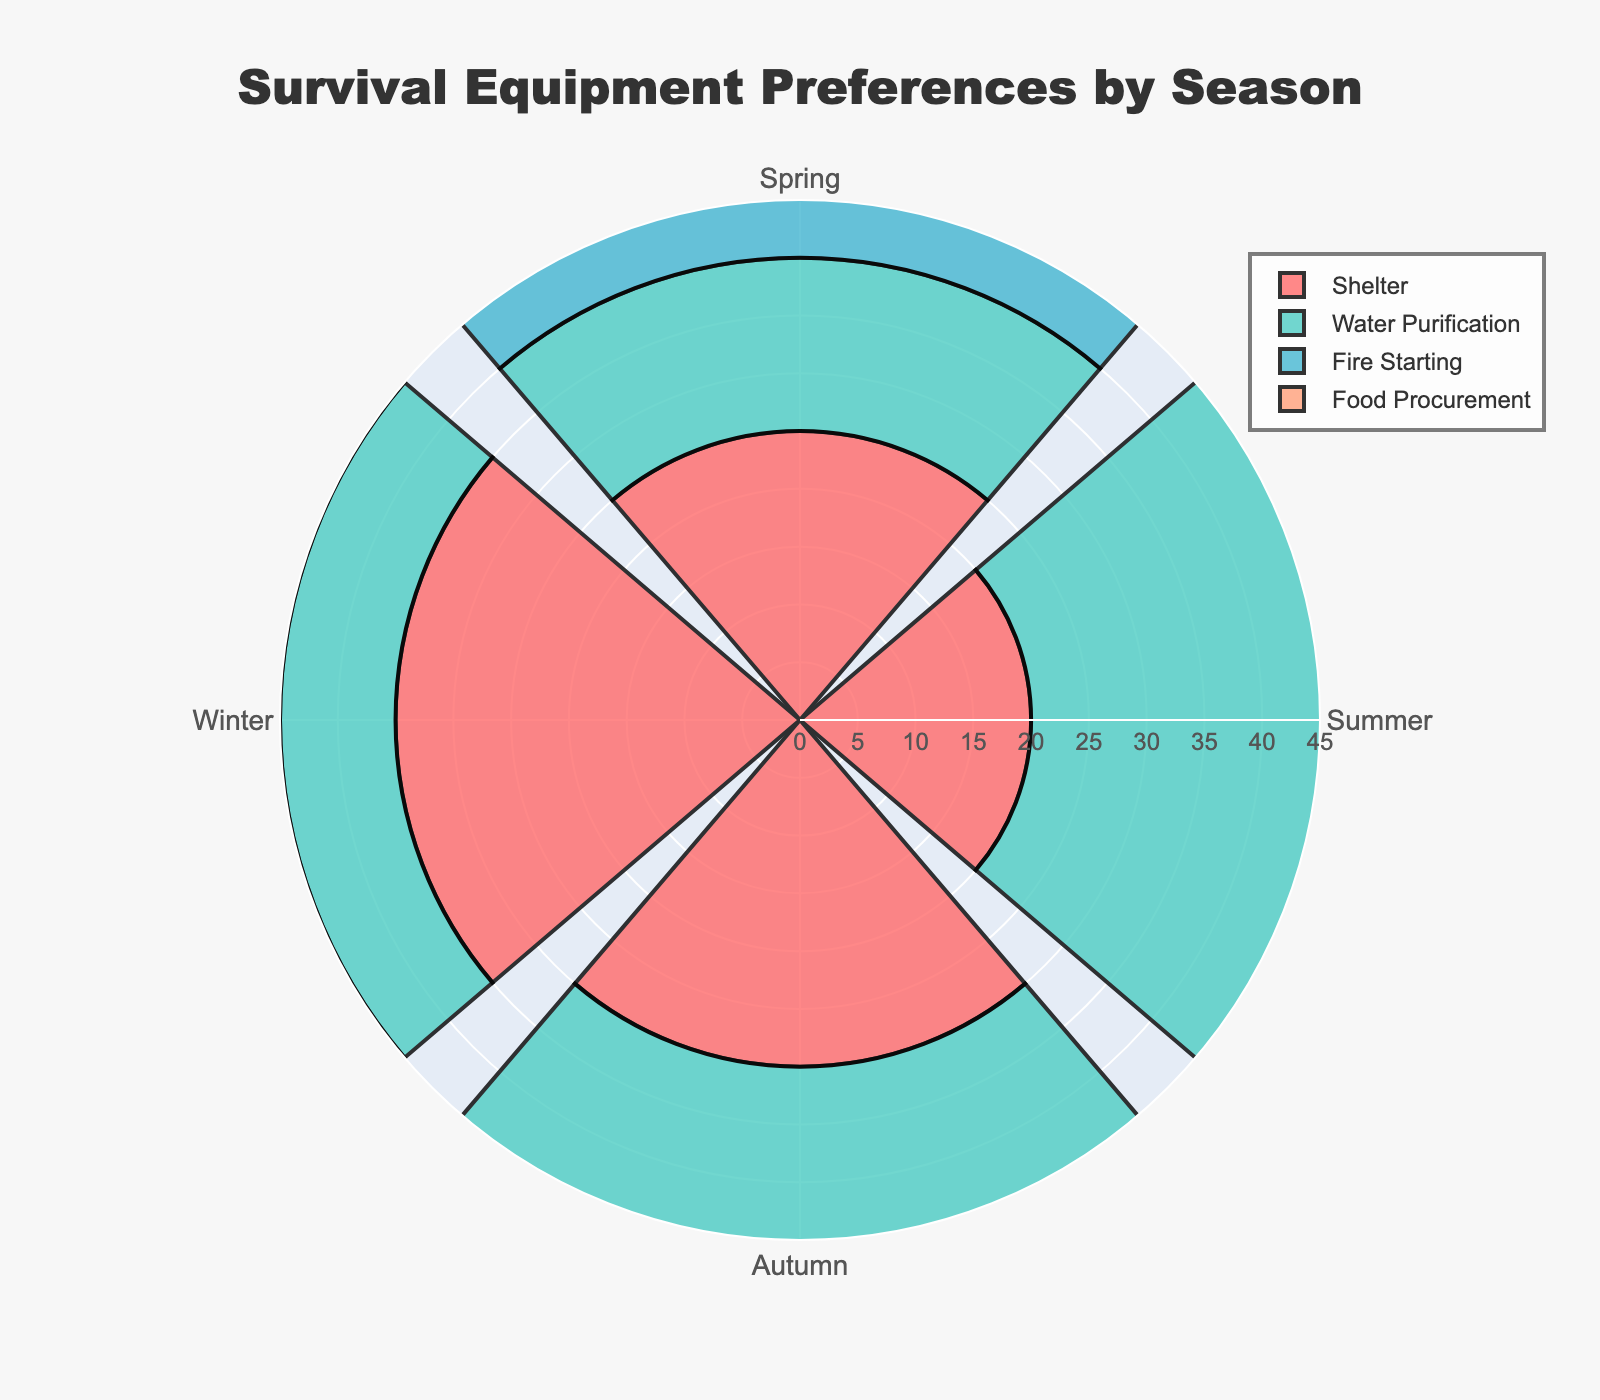What is the title of the rose chart? The title is found at the top of the chart, providing a summary of the content depicted in the figure.
Answer: Survival Equipment Preferences by Season How many seasons are represented in the chart? Each season is indicated by a distinct segment within the rose chart.
Answer: Four Which category has the highest usage in Winter? By looking at the length of the bar in the Winter slice of the rose chart, we can determine which category has the highest value.
Answer: Fire Starting What is the total value for Shelter across all seasons? Add the values of Shelter from Spring, Summer, Autumn, and Winter: 25 + 20 + 30 + 35.
Answer: 110 How does Shelter usage differ between Autumn and Winter? Subtract the value of Shelter in Autumn from its value in Winter: 35 - 30.
Answer: 5 In which season is Water Purification usage the highest? Compare the Water Purification values across all seasons to find the highest one.
Answer: Summer Which category has the least usage in Summer? Compare all categories within the Summer slice to find the one with the smallest bar.
Answer: Fire Starting Between Spring and Autumn, which season has a higher total preference for all categories combined? Add the values for all categories in both seasons and compare: Spring (25+15+20+30), Autumn (30+20+25+25).
Answer: Autumn Is Food Procurement usage in Autumn greater than in Winter? Compare the bars for Food Procurement in Autumn and Winter.
Answer: Yes 